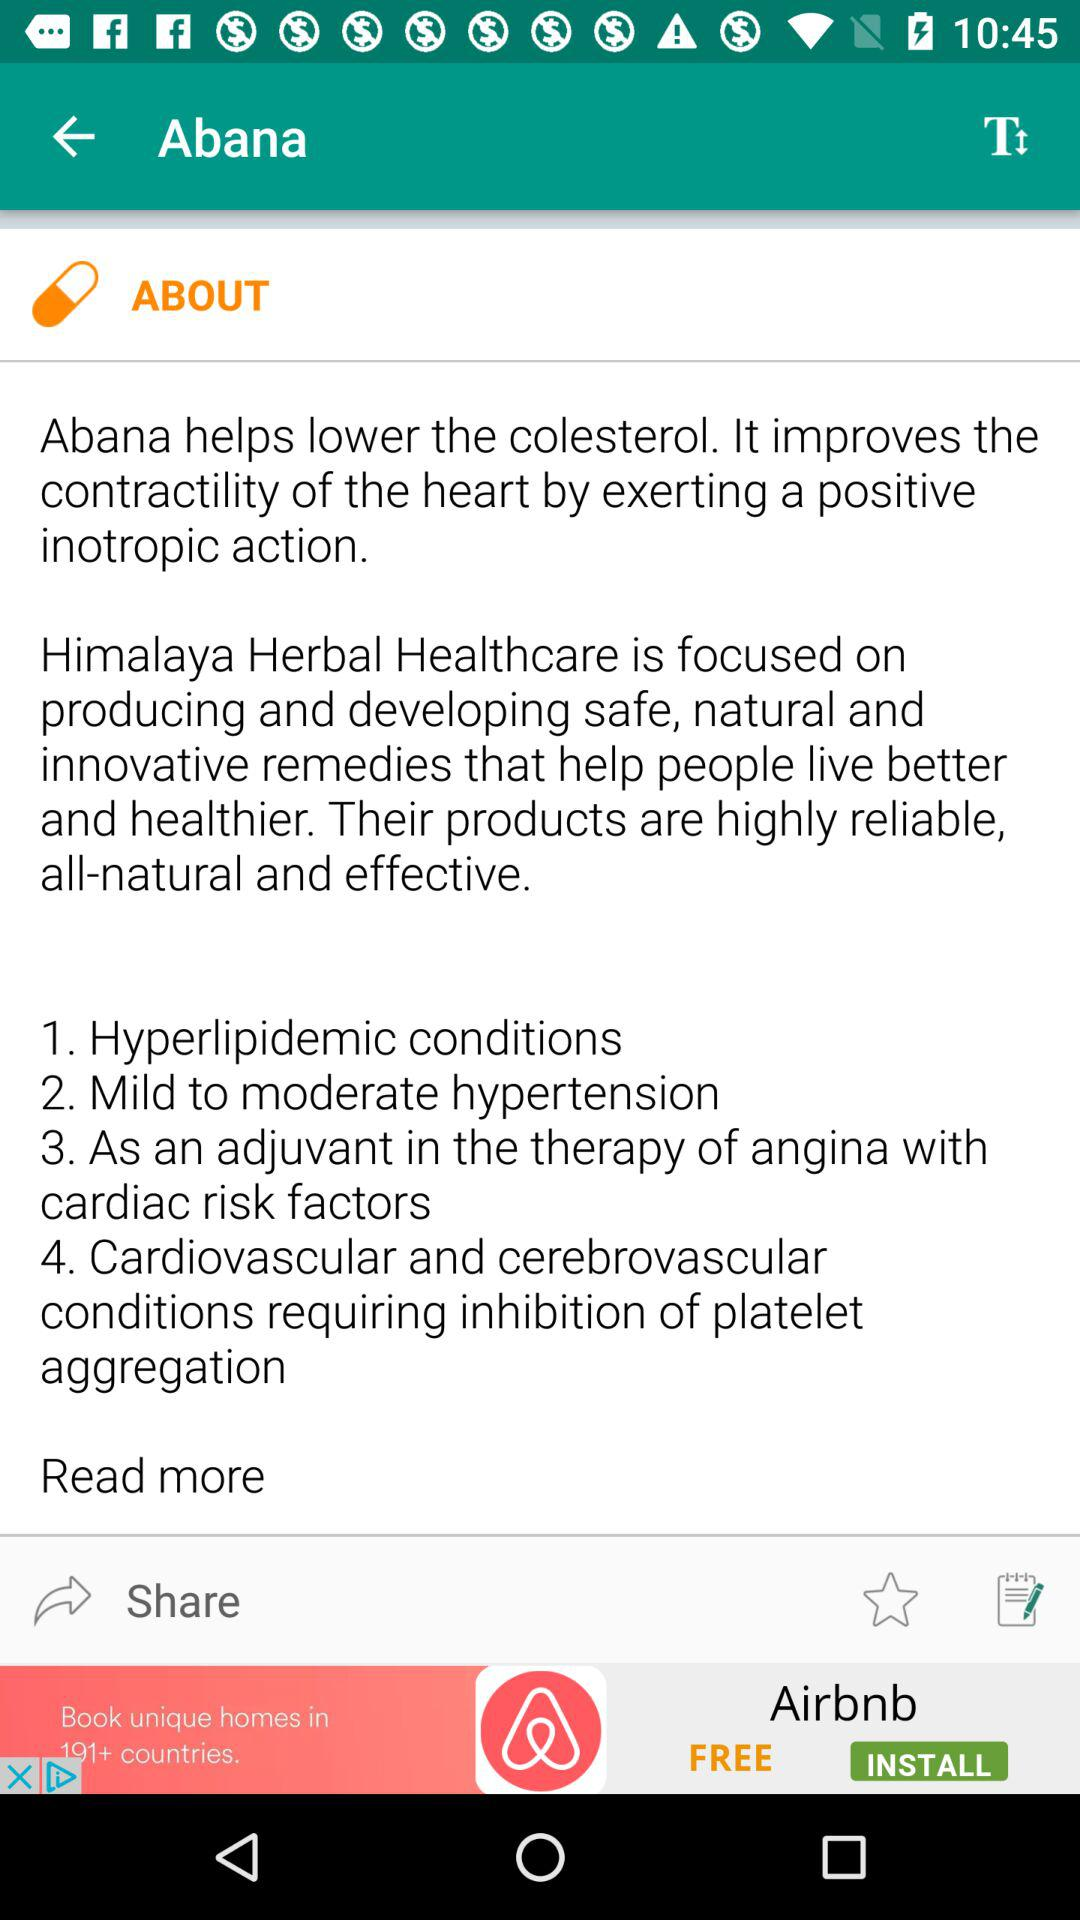What is Abana?
Answer the question using a single word or phrase. Abana helps lower the colesterol. It improves the contractility of the heart by exerting a positive inotropic action. Himalaya Herbal Healthcare is focused on producing and developing safe, natural and innovative remedies that help people live better and healthier. Their products are highly reliable, all-natural and effective. 1. Hyperlipidemic conditions 2. Mild to moderate hypertension 3. As an adjuvant in the therapy of angina with cardiac risk factors 4. Cardiovascular and cerebrovascular conditions requiring inhibition of platelet aggregation 